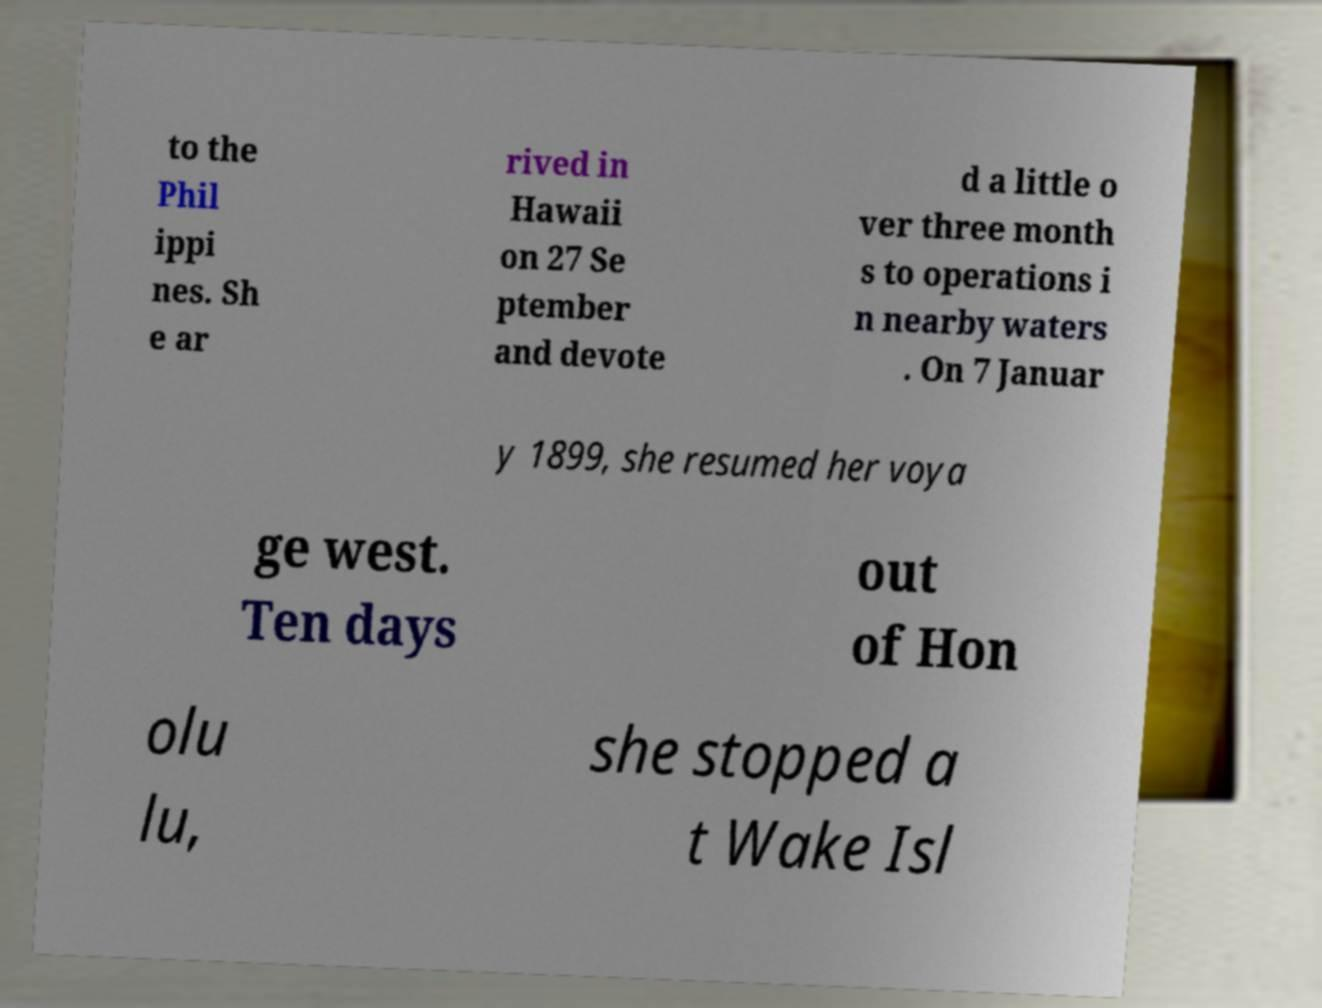Can you read and provide the text displayed in the image?This photo seems to have some interesting text. Can you extract and type it out for me? to the Phil ippi nes. Sh e ar rived in Hawaii on 27 Se ptember and devote d a little o ver three month s to operations i n nearby waters . On 7 Januar y 1899, she resumed her voya ge west. Ten days out of Hon olu lu, she stopped a t Wake Isl 